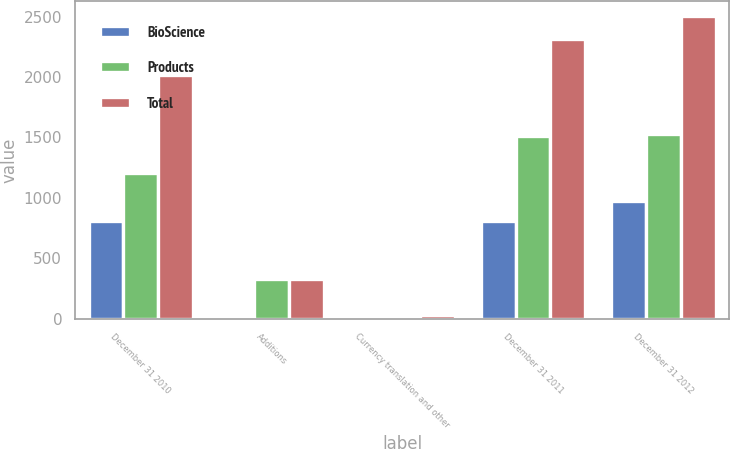Convert chart to OTSL. <chart><loc_0><loc_0><loc_500><loc_500><stacked_bar_chart><ecel><fcel>December 31 2010<fcel>Additions<fcel>Currency translation and other<fcel>December 31 2011<fcel>December 31 2012<nl><fcel>BioScience<fcel>809<fcel>1<fcel>4<fcel>806<fcel>975<nl><fcel>Products<fcel>1206<fcel>328<fcel>23<fcel>1511<fcel>1527<nl><fcel>Total<fcel>2015<fcel>329<fcel>27<fcel>2317<fcel>2502<nl></chart> 